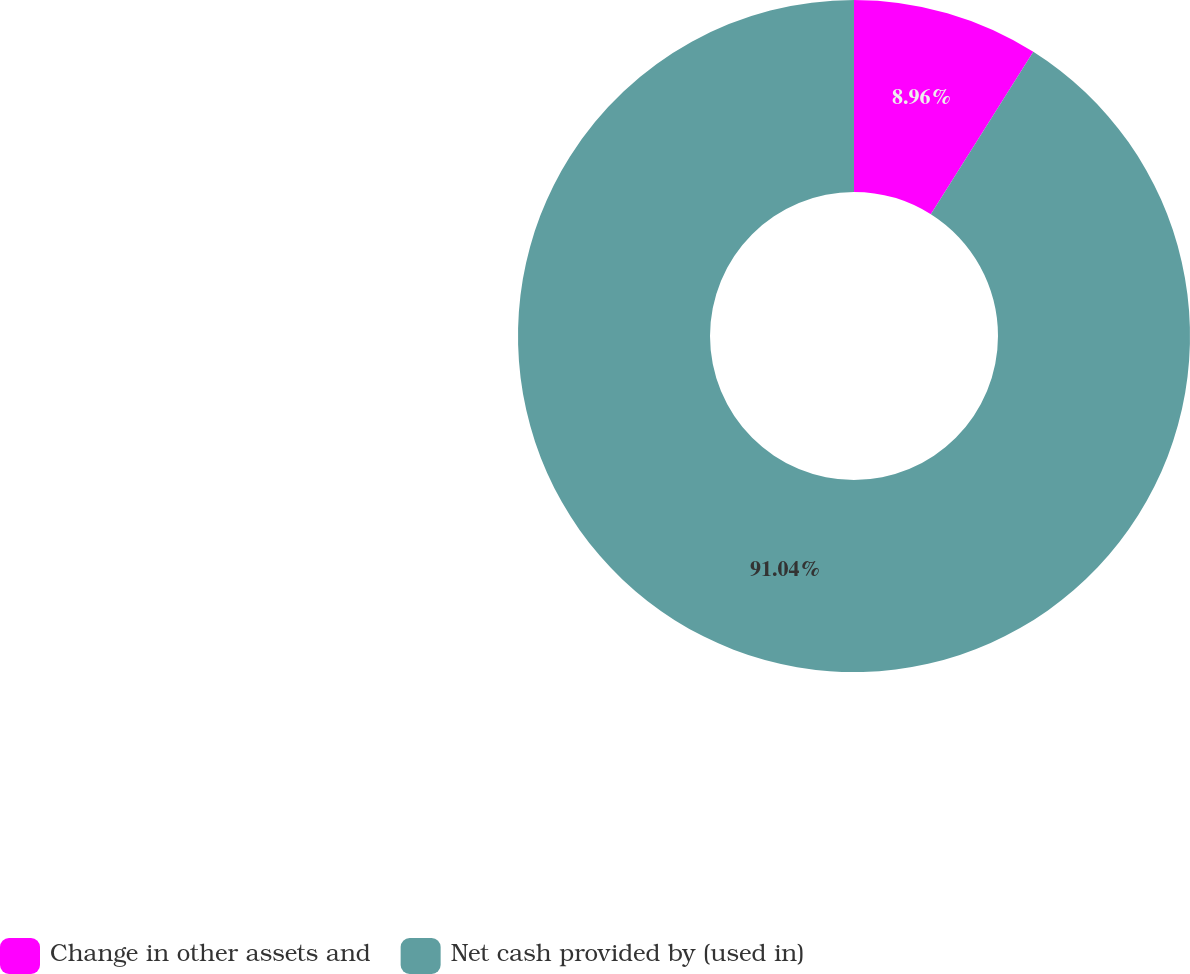<chart> <loc_0><loc_0><loc_500><loc_500><pie_chart><fcel>Change in other assets and<fcel>Net cash provided by (used in)<nl><fcel>8.96%<fcel>91.04%<nl></chart> 